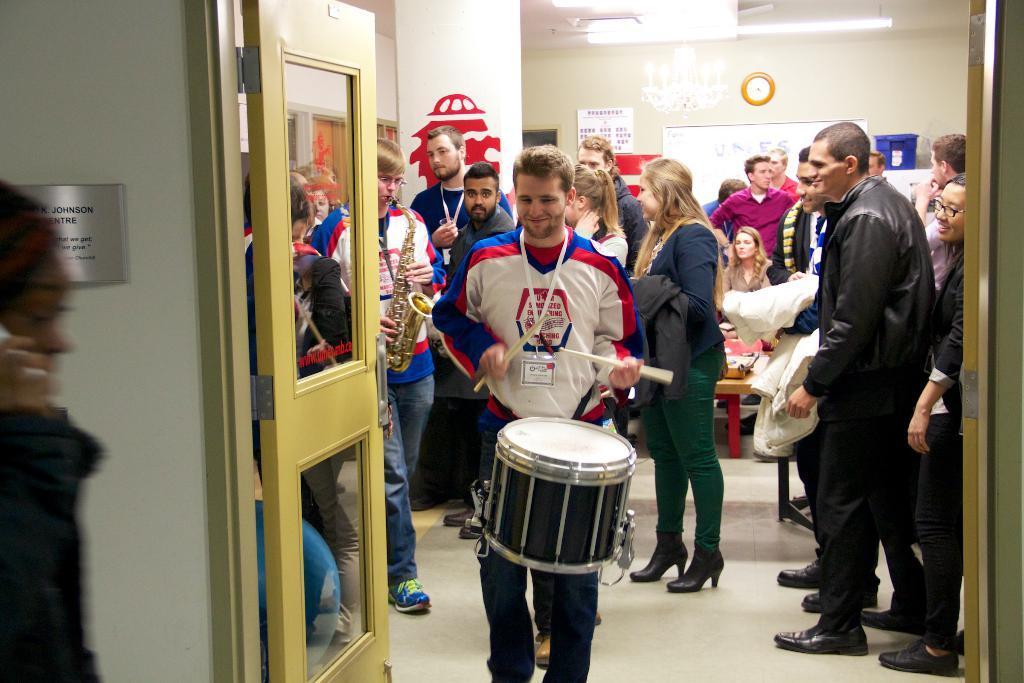Please provide a concise description of this image. As we can see in the image there is a white color wall, door, few people standing and sitting here and there and there are few people playing different types of musical instruments. 